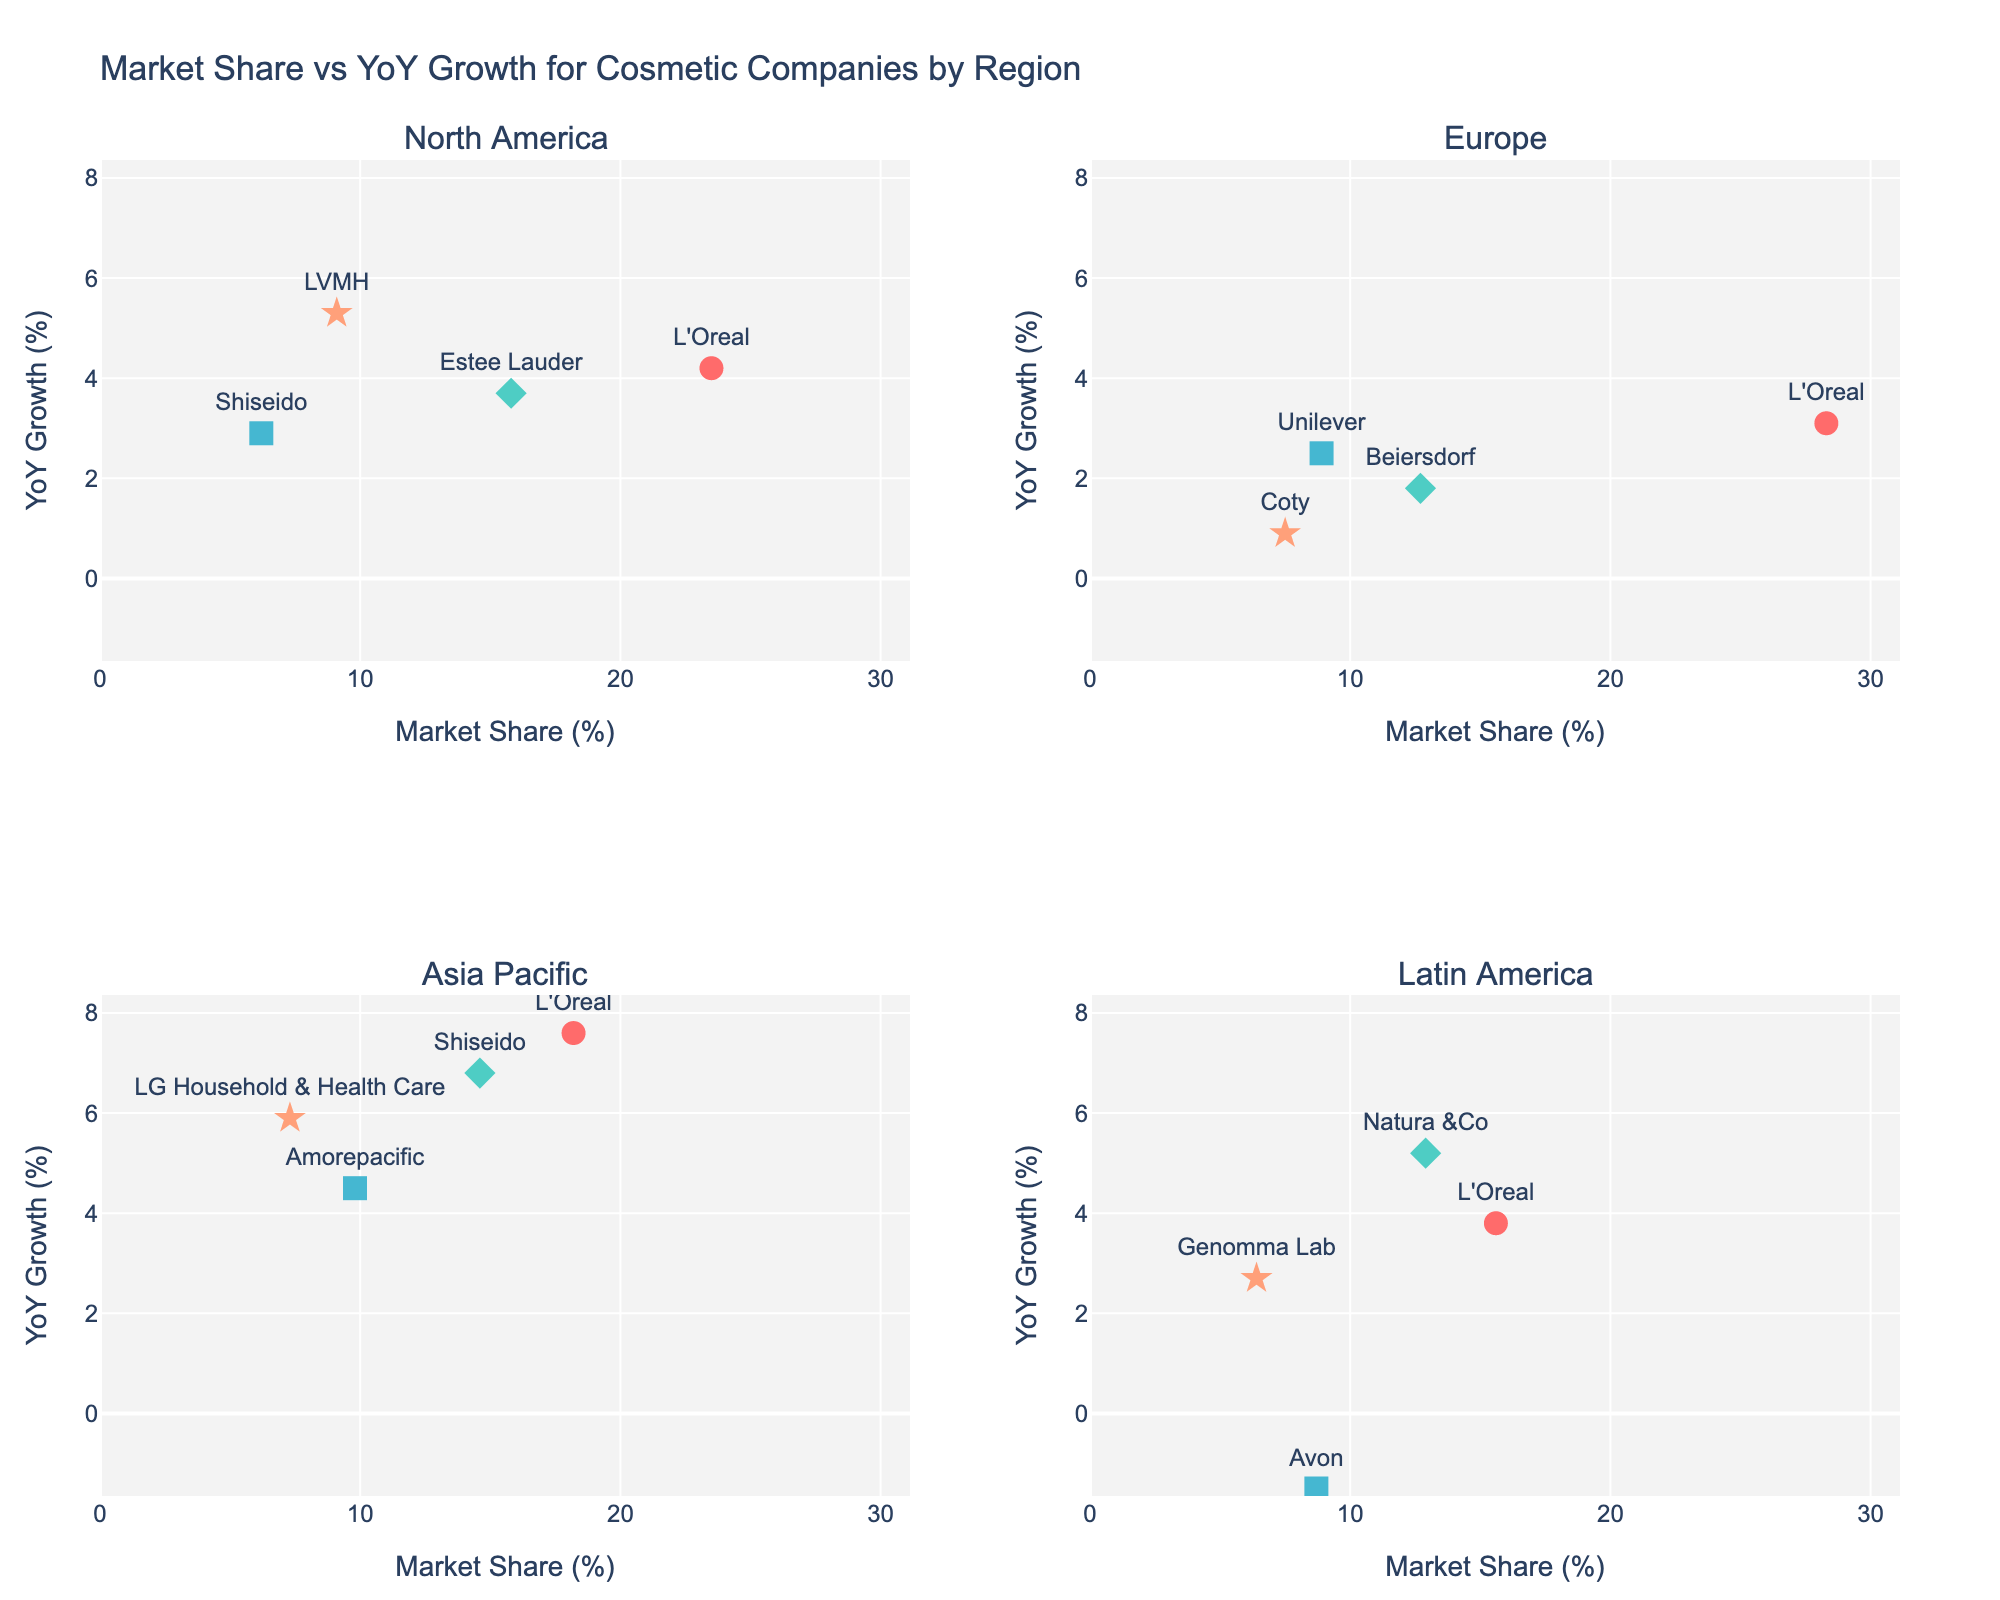Which region has the highest number of data points? By counting the number of companies for each region in the subplots, we see that Asia Pacific has four data points (L'Oreal, Shiseido, Amorepacific, LG Household & Health Care), which is the highest.
Answer: Asia Pacific Which company has the highest year-over-year growth rate in Latin America? Looking at the subplot for Latin America, the highest YoY growth rate is for Natura &Co with 5.2%.
Answer: Natura &Co Is there any company with negative year-over-year growth? If so, which one and in which region? By examining the plots, Avon in Latin America has a negative year-over-year growth rate of -1.5%.
Answer: Avon, Latin America Which companies in North America have a market share greater than 10%? In the North America subplot, the companies with a market share greater than 10% are L'Oreal (23.5%) and Estee Lauder (15.8%).
Answer: L'Oreal, Estee Lauder Compare the market share of L'Oreal in Europe and Asia Pacific. Which region has L'Oreal a higher market share? L'Oreal has a market share of 28.3% in Europe and 18.2% in Asia Pacific. Therefore, L'Oreal has a higher market share in Europe.
Answer: Europe Which region shows the highest YoY growth rate for Shiseido? By looking at the subplots, Shiseido's highest YoY growth rate is in Asia Pacific with 6.8%. In North America, it is 2.9%.
Answer: Asia Pacific What is the difference in market share between Genomma Lab and LVMH? LVMH in North America has a market share of 9.1%, and Genomma Lab in Latin America has a market share of 6.4%. The difference is 9.1 - 6.4 = 2.7.
Answer: 2.7 How does the market share of Beiersdorf in Europe compare to Unilever in Europe? Beiersdorf has a market share of 12.7% in Europe, while Unilever has 8.9%. Beiersdorf's market share is higher.
Answer: Beiersdorf Which company shows the highest market share in North America, and what is it? In the North America subplot, L'Oreal has the highest market share with 23.5%.
Answer: L'Oreal, 23.5% What is the average YoY growth rate for all companies in Asia Pacific? The YoY growth rates for companies in Asia Pacific are L'Oreal (7.6), Shiseido (6.8), Amorepacific (4.5), and LG Household & Health Care (5.9). The average is calculated as (7.6 + 6.8 + 4.5 + 5.9) / 4 = 6.2.
Answer: 6.2 